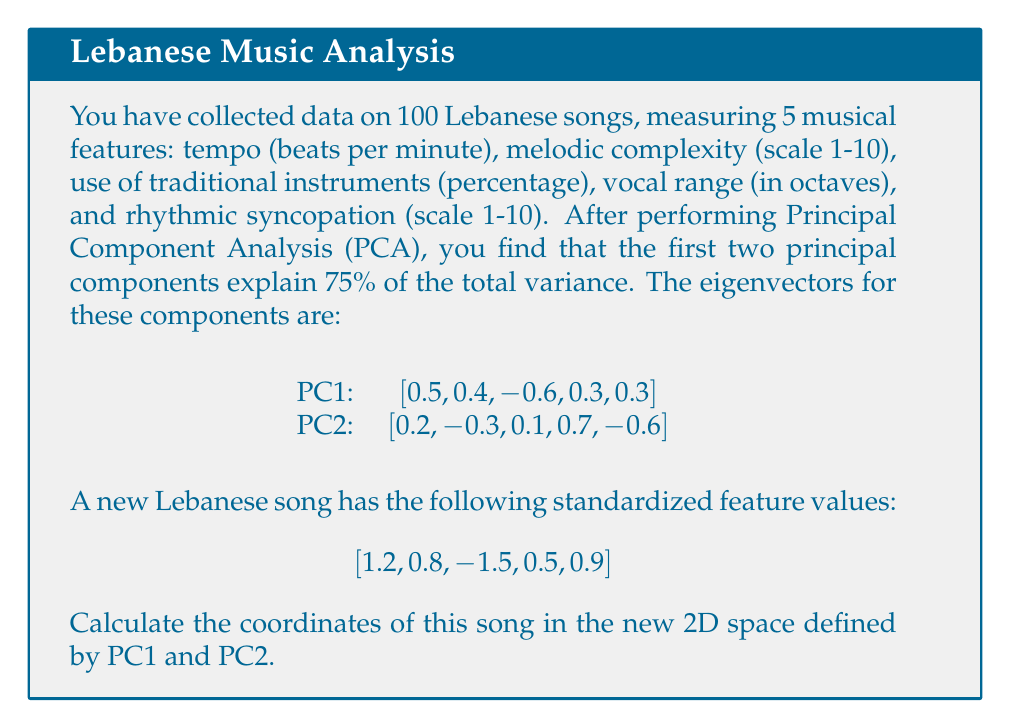Give your solution to this math problem. To find the coordinates of the song in the new 2D space defined by PC1 and PC2, we need to project the standardized feature values onto these principal components. This is done by calculating the dot product of the feature vector with each principal component.

Let's go through this step-by-step:

1. We have the standardized feature vector:
   $$\mathbf{x} = [1.2, 0.8, -1.5, 0.5, 0.9]$$

2. The eigenvector for PC1 is:
   $$\mathbf{v}_1 = [0.5, 0.4, -0.6, 0.3, 0.3]$$

3. The eigenvector for PC2 is:
   $$\mathbf{v}_2 = [0.2, -0.3, 0.1, 0.7, -0.6]$$

4. To find the coordinate on PC1, we calculate the dot product of $\mathbf{x}$ and $\mathbf{v}_1$:
   $$\begin{align}
   PC1_{coord} &= \mathbf{x} \cdot \mathbf{v}_1 \\
   &= (1.2 \times 0.5) + (0.8 \times 0.4) + (-1.5 \times -0.6) + (0.5 \times 0.3) + (0.9 \times 0.3) \\
   &= 0.6 + 0.32 + 0.9 + 0.15 + 0.27 \\
   &= 2.24
   \end{align}$$

5. Similarly, for PC2:
   $$\begin{align}
   PC2_{coord} &= \mathbf{x} \cdot \mathbf{v}_2 \\
   &= (1.2 \times 0.2) + (0.8 \times -0.3) + (-1.5 \times 0.1) + (0.5 \times 0.7) + (0.9 \times -0.6) \\
   &= 0.24 - 0.24 - 0.15 + 0.35 - 0.54 \\
   &= -0.34
   \end{align}$$

Therefore, the coordinates of the song in the new 2D space are (2.24, -0.34).
Answer: (2.24, -0.34) 